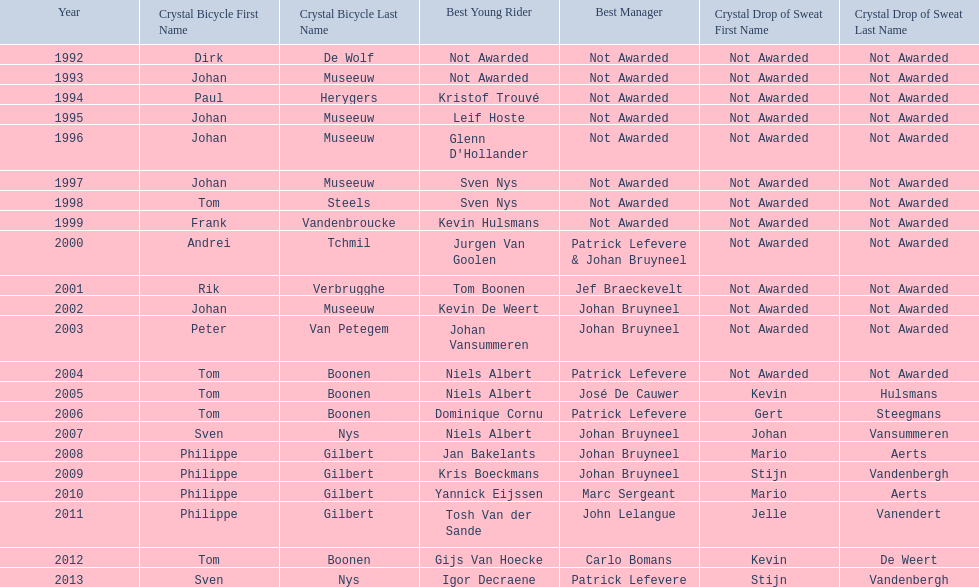Who has won the most best young rider awards? Niels Albert. 